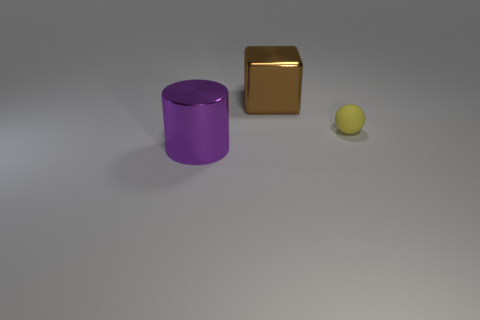How big is the thing that is both left of the small yellow matte object and in front of the metallic cube?
Keep it short and to the point. Large. Is the material of the big object behind the matte ball the same as the big purple thing?
Your answer should be very brief. Yes. Are there any other things that are made of the same material as the small sphere?
Ensure brevity in your answer.  No. What color is the object that is the same size as the purple cylinder?
Ensure brevity in your answer.  Brown. How many other things are the same size as the metallic cube?
Your response must be concise. 1. There is a yellow ball on the right side of the metal cylinder; what is its material?
Keep it short and to the point. Rubber. There is a large metallic object that is on the right side of the big shiny thing in front of the big thing that is on the right side of the purple thing; what shape is it?
Your answer should be compact. Cube. Does the purple object have the same size as the ball?
Your answer should be very brief. No. How many objects are tiny brown metallic cubes or big shiny things that are in front of the small yellow thing?
Your response must be concise. 1. What number of objects are either big shiny things left of the brown cube or objects behind the metallic cylinder?
Offer a very short reply. 3. 